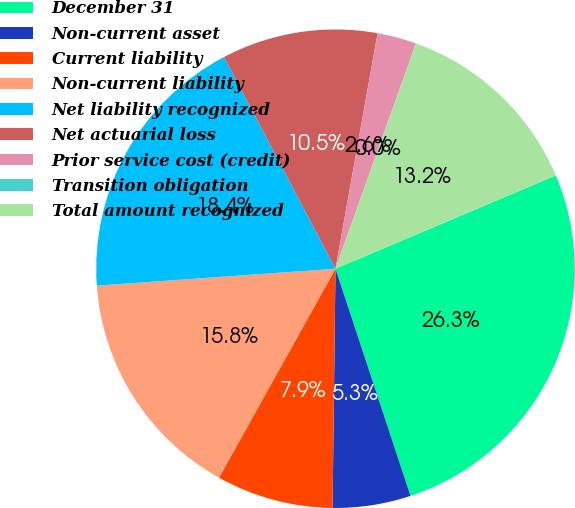Convert chart to OTSL. <chart><loc_0><loc_0><loc_500><loc_500><pie_chart><fcel>December 31<fcel>Non-current asset<fcel>Current liability<fcel>Non-current liability<fcel>Net liability recognized<fcel>Net actuarial loss<fcel>Prior service cost (credit)<fcel>Transition obligation<fcel>Total amount recognized<nl><fcel>26.3%<fcel>5.27%<fcel>7.9%<fcel>15.78%<fcel>18.41%<fcel>10.53%<fcel>2.64%<fcel>0.01%<fcel>13.16%<nl></chart> 